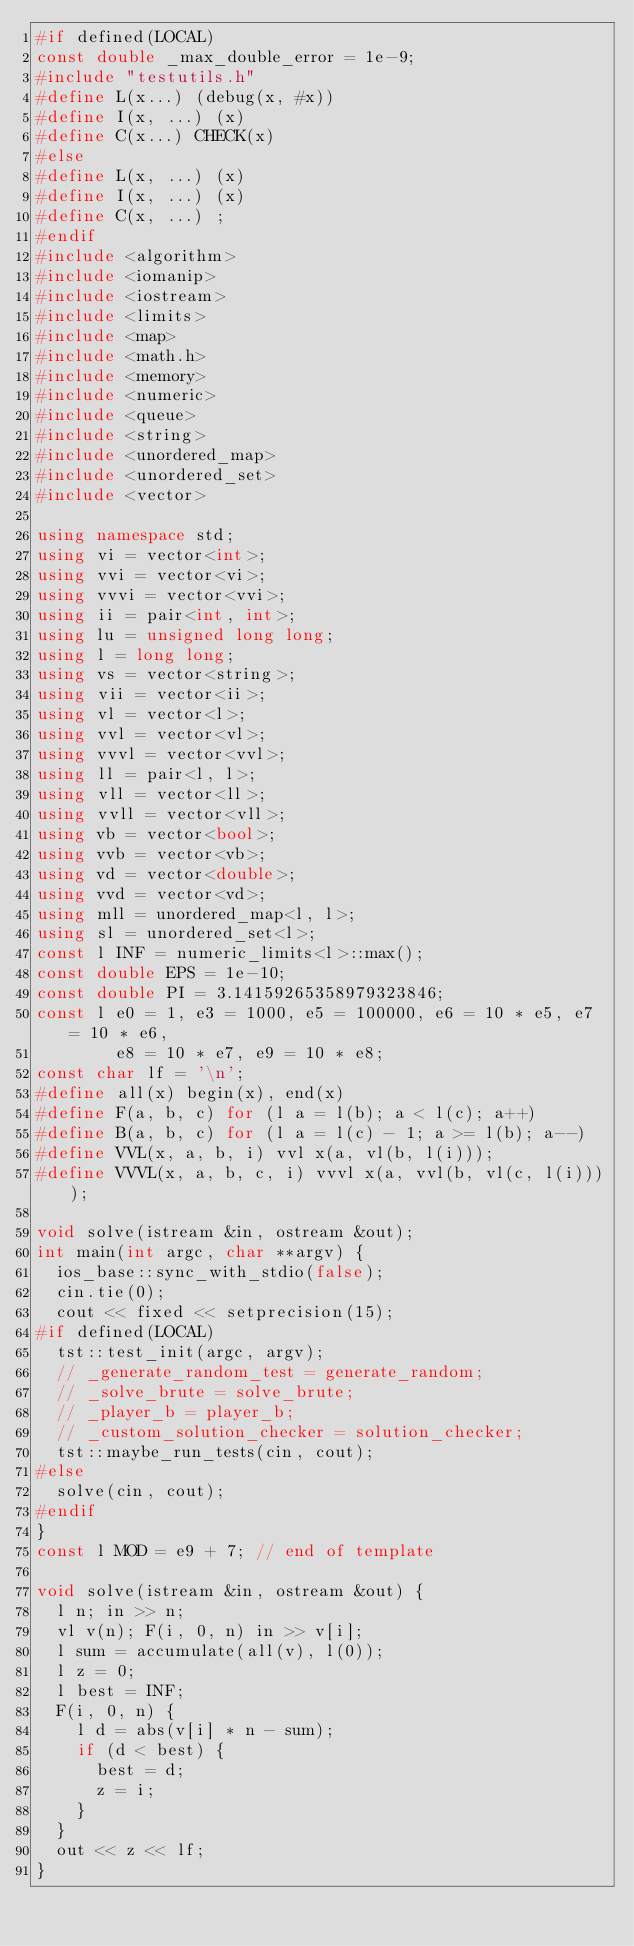Convert code to text. <code><loc_0><loc_0><loc_500><loc_500><_C++_>#if defined(LOCAL)
const double _max_double_error = 1e-9;
#include "testutils.h"
#define L(x...) (debug(x, #x))
#define I(x, ...) (x)
#define C(x...) CHECK(x)
#else
#define L(x, ...) (x)
#define I(x, ...) (x)
#define C(x, ...) ;
#endif
#include <algorithm>
#include <iomanip>
#include <iostream>
#include <limits>
#include <map>
#include <math.h>
#include <memory>
#include <numeric>
#include <queue>
#include <string>
#include <unordered_map>
#include <unordered_set>
#include <vector>

using namespace std;
using vi = vector<int>;
using vvi = vector<vi>;
using vvvi = vector<vvi>;
using ii = pair<int, int>;
using lu = unsigned long long;
using l = long long;
using vs = vector<string>;
using vii = vector<ii>;
using vl = vector<l>;
using vvl = vector<vl>;
using vvvl = vector<vvl>;
using ll = pair<l, l>;
using vll = vector<ll>;
using vvll = vector<vll>;
using vb = vector<bool>;
using vvb = vector<vb>;
using vd = vector<double>;
using vvd = vector<vd>;
using mll = unordered_map<l, l>;
using sl = unordered_set<l>;
const l INF = numeric_limits<l>::max();
const double EPS = 1e-10;
const double PI = 3.14159265358979323846;
const l e0 = 1, e3 = 1000, e5 = 100000, e6 = 10 * e5, e7 = 10 * e6,
        e8 = 10 * e7, e9 = 10 * e8;
const char lf = '\n';
#define all(x) begin(x), end(x)
#define F(a, b, c) for (l a = l(b); a < l(c); a++)
#define B(a, b, c) for (l a = l(c) - 1; a >= l(b); a--)
#define VVL(x, a, b, i) vvl x(a, vl(b, l(i)));
#define VVVL(x, a, b, c, i) vvvl x(a, vvl(b, vl(c, l(i))));

void solve(istream &in, ostream &out);
int main(int argc, char **argv) {
  ios_base::sync_with_stdio(false);
  cin.tie(0);
  cout << fixed << setprecision(15);
#if defined(LOCAL)
  tst::test_init(argc, argv);
  // _generate_random_test = generate_random;
  // _solve_brute = solve_brute;
  // _player_b = player_b;
  // _custom_solution_checker = solution_checker;
  tst::maybe_run_tests(cin, cout);
#else
  solve(cin, cout);
#endif
}
const l MOD = e9 + 7; // end of template

void solve(istream &in, ostream &out) {
  l n; in >> n;
  vl v(n); F(i, 0, n) in >> v[i];
  l sum = accumulate(all(v), l(0));
  l z = 0;
  l best = INF;
  F(i, 0, n) {
    l d = abs(v[i] * n - sum);
    if (d < best) {
      best = d;
      z = i;
    }
  }
  out << z << lf;
}
</code> 